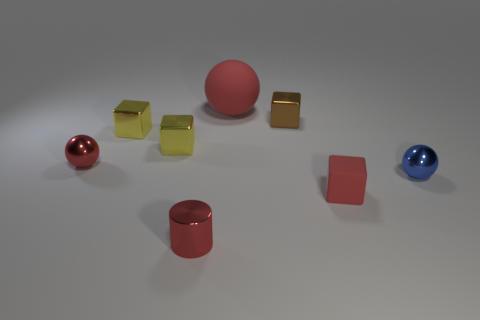There is a tiny metal ball to the left of the big rubber object; does it have the same color as the tiny metallic cylinder? yes 